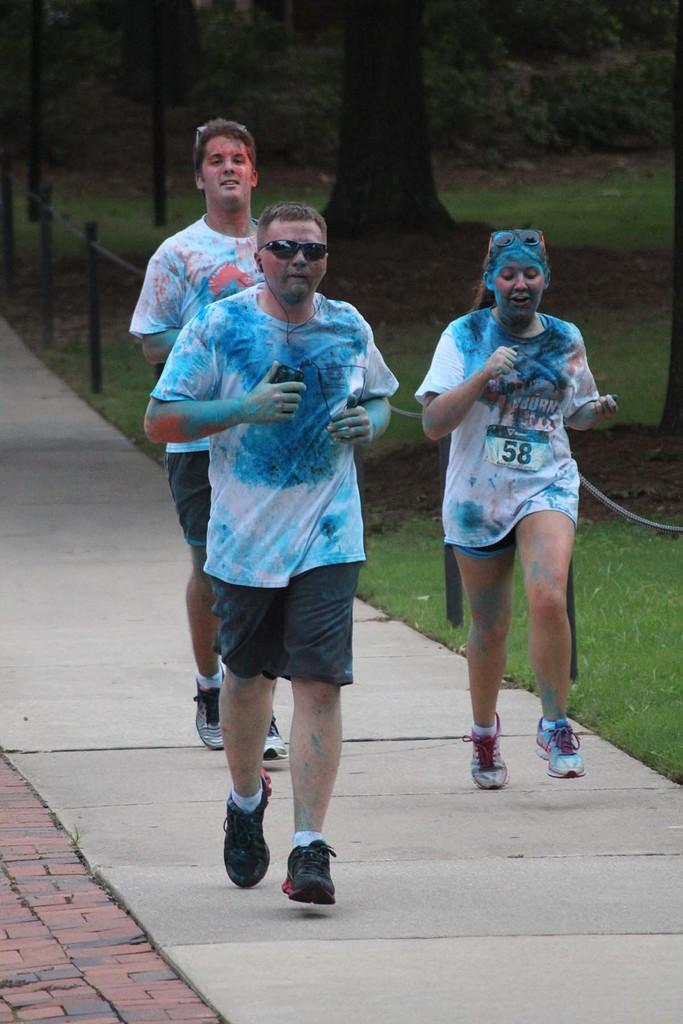What are the three persons in the image doing? The three persons are running in the image. Where are the persons running? The persons are running on a road. What can be seen in the background of the image? There are trees and poles behind a railing visible in the background. What type of vegetation is visible at the bottom of the image? There is grass visible at the bottom of the image. What is the main surface that the persons are running on? There is a road in the image, which is the main surface that the persons are running on. What color is the banana that the person is holding while running in the image? There is no banana present in the image; the persons are running without holding any objects. How many flies can be seen buzzing around the person running in the image? There are no flies visible in the image; the focus is on the persons running and the surrounding environment. 